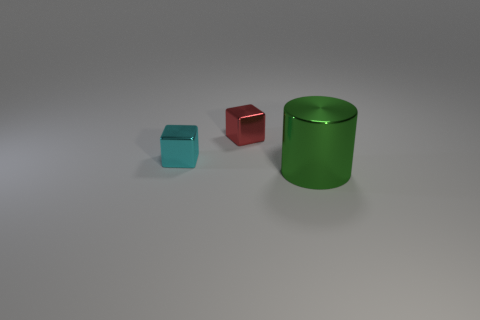Could you describe the lighting and texture details in the scene? The scene is softly lit, with the light source seemingly positioned above the objects, casting gentle shadows beneath them. The surface texture of the objects is smooth and reflective, which is seen in the subtle highlights and the soft reflection on the ground, indicating a non-glossy but well-polished surface quality. 